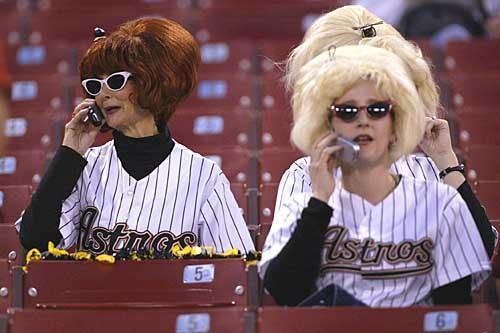How many chairs are visible?
Give a very brief answer. 4. 